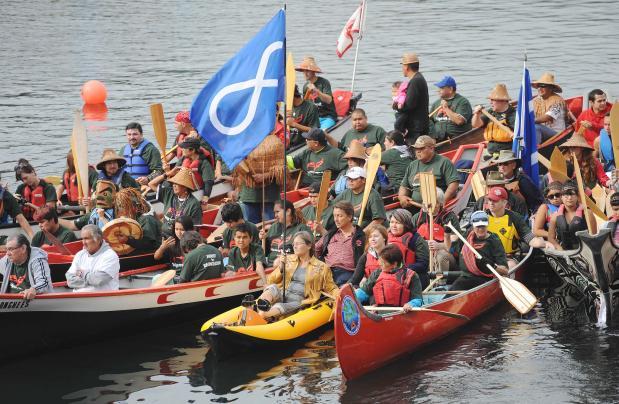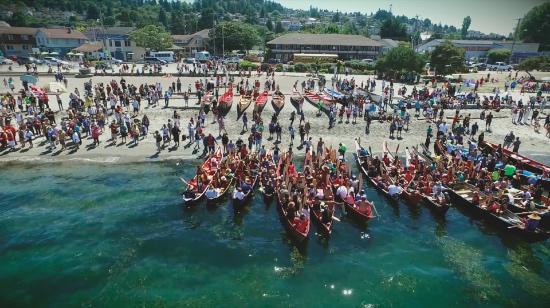The first image is the image on the left, the second image is the image on the right. Assess this claim about the two images: "There is a single man paddling a kayak in the left image.". Correct or not? Answer yes or no. No. The first image is the image on the left, the second image is the image on the right. Given the left and right images, does the statement "An image shows a single boat, which has at least four rowers." hold true? Answer yes or no. No. 